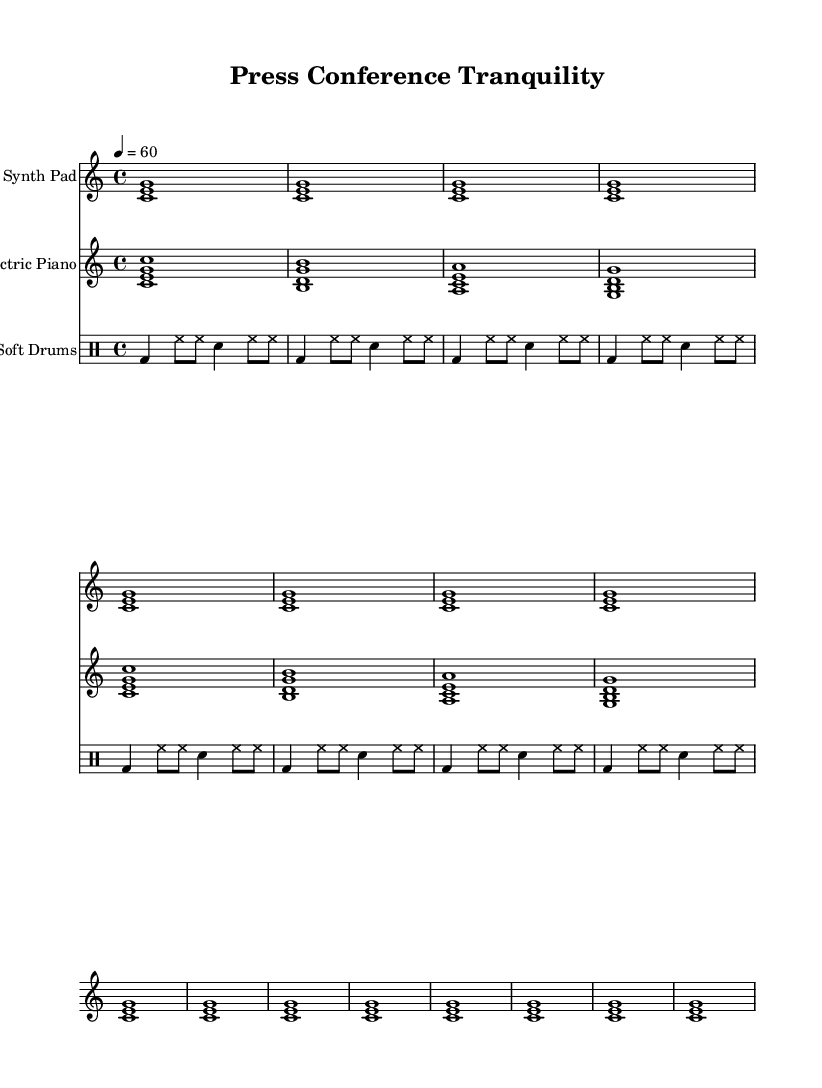What is the key signature of this music? The key signature is C major, which is indicated at the beginning of the staff with no sharps or flats shown.
Answer: C major What is the time signature of this music? The time signature is 4/4, which appears after the key signature, indicating four beats per measure.
Answer: 4/4 What is the tempo of the piece? The tempo marking at the beginning indicates a speed of 60 beats per minute, meaning one beat occurs every second.
Answer: 60 How many measures are in the Synth Pad part? The Synth Pad part consists of 16 measures, as determined by counting the repeated sections and the number of bars in the score.
Answer: 16 Which instruments are included in this composition? Three instruments are present: Synth Pad, Electric Piano, and Soft Drums, each indicated by the instrument names at the beginning of their respective staves.
Answer: Synth Pad, Electric Piano, Soft Drums What kind of rhythmic elements are used in the Soft Drums part? The Soft Drums include a combination of bass drum, hi-hat, and snare drum patterns, which create a soft, steady rhythmic accompaniment.
Answer: Bass drum, hi-hat, snare Which section has the highest note in the piece? The Electric Piano section contains the highest notes, particularly the high C, found in the chord played at the start.
Answer: Electric Piano 